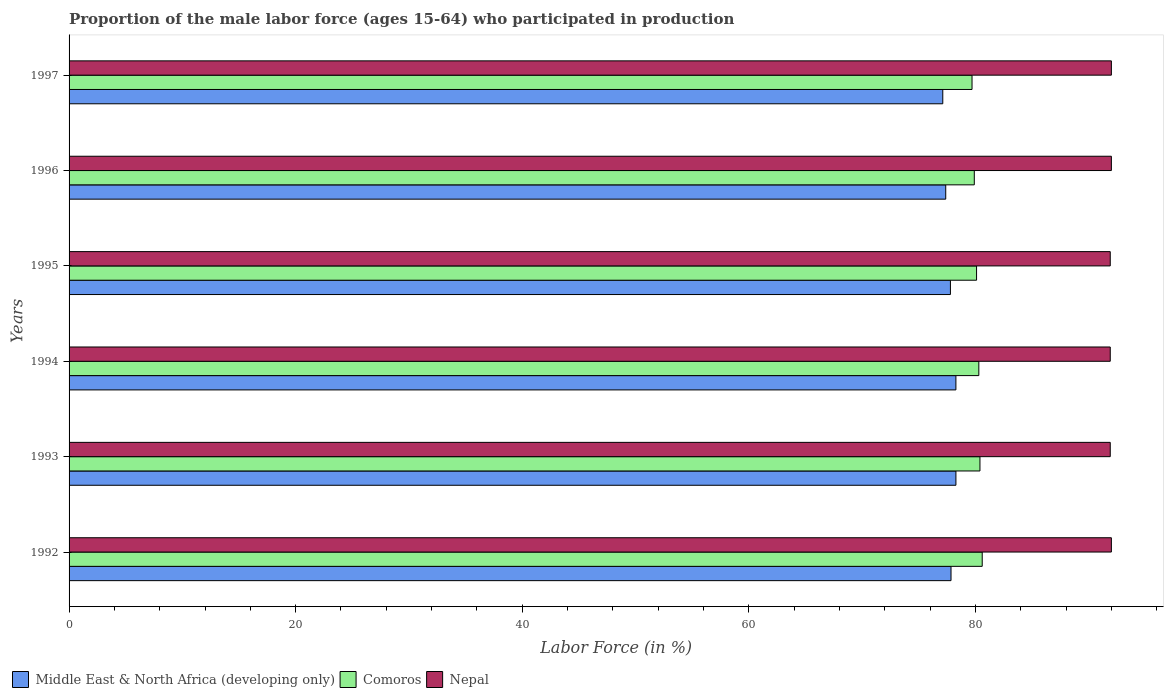How many different coloured bars are there?
Offer a very short reply. 3. How many groups of bars are there?
Keep it short and to the point. 6. Are the number of bars per tick equal to the number of legend labels?
Your response must be concise. Yes. How many bars are there on the 5th tick from the top?
Give a very brief answer. 3. How many bars are there on the 4th tick from the bottom?
Your response must be concise. 3. In how many cases, is the number of bars for a given year not equal to the number of legend labels?
Make the answer very short. 0. What is the proportion of the male labor force who participated in production in Comoros in 1997?
Make the answer very short. 79.7. Across all years, what is the maximum proportion of the male labor force who participated in production in Middle East & North Africa (developing only)?
Your response must be concise. 78.28. Across all years, what is the minimum proportion of the male labor force who participated in production in Comoros?
Your answer should be compact. 79.7. What is the total proportion of the male labor force who participated in production in Nepal in the graph?
Provide a short and direct response. 551.7. What is the difference between the proportion of the male labor force who participated in production in Middle East & North Africa (developing only) in 1994 and that in 1995?
Your answer should be very brief. 0.48. What is the difference between the proportion of the male labor force who participated in production in Comoros in 1994 and the proportion of the male labor force who participated in production in Middle East & North Africa (developing only) in 1992?
Keep it short and to the point. 2.45. What is the average proportion of the male labor force who participated in production in Comoros per year?
Make the answer very short. 80.17. In the year 1995, what is the difference between the proportion of the male labor force who participated in production in Nepal and proportion of the male labor force who participated in production in Middle East & North Africa (developing only)?
Provide a short and direct response. 14.11. In how many years, is the proportion of the male labor force who participated in production in Comoros greater than 76 %?
Make the answer very short. 6. What is the ratio of the proportion of the male labor force who participated in production in Comoros in 1992 to that in 1994?
Make the answer very short. 1. Is the proportion of the male labor force who participated in production in Middle East & North Africa (developing only) in 1993 less than that in 1997?
Provide a succinct answer. No. What is the difference between the highest and the second highest proportion of the male labor force who participated in production in Comoros?
Keep it short and to the point. 0.2. What is the difference between the highest and the lowest proportion of the male labor force who participated in production in Comoros?
Offer a terse response. 0.9. What does the 2nd bar from the top in 1996 represents?
Make the answer very short. Comoros. What does the 1st bar from the bottom in 1995 represents?
Your answer should be compact. Middle East & North Africa (developing only). How many bars are there?
Ensure brevity in your answer.  18. Are all the bars in the graph horizontal?
Your response must be concise. Yes. Are the values on the major ticks of X-axis written in scientific E-notation?
Make the answer very short. No. Does the graph contain any zero values?
Offer a terse response. No. Does the graph contain grids?
Offer a terse response. No. How many legend labels are there?
Provide a short and direct response. 3. How are the legend labels stacked?
Your response must be concise. Horizontal. What is the title of the graph?
Keep it short and to the point. Proportion of the male labor force (ages 15-64) who participated in production. What is the Labor Force (in %) of Middle East & North Africa (developing only) in 1992?
Offer a terse response. 77.85. What is the Labor Force (in %) in Comoros in 1992?
Your answer should be very brief. 80.6. What is the Labor Force (in %) of Nepal in 1992?
Make the answer very short. 92. What is the Labor Force (in %) of Middle East & North Africa (developing only) in 1993?
Your answer should be compact. 78.28. What is the Labor Force (in %) in Comoros in 1993?
Your answer should be compact. 80.4. What is the Labor Force (in %) in Nepal in 1993?
Ensure brevity in your answer.  91.9. What is the Labor Force (in %) in Middle East & North Africa (developing only) in 1994?
Make the answer very short. 78.28. What is the Labor Force (in %) of Comoros in 1994?
Keep it short and to the point. 80.3. What is the Labor Force (in %) in Nepal in 1994?
Your answer should be very brief. 91.9. What is the Labor Force (in %) of Middle East & North Africa (developing only) in 1995?
Offer a very short reply. 77.79. What is the Labor Force (in %) in Comoros in 1995?
Offer a terse response. 80.1. What is the Labor Force (in %) of Nepal in 1995?
Your response must be concise. 91.9. What is the Labor Force (in %) of Middle East & North Africa (developing only) in 1996?
Ensure brevity in your answer.  77.38. What is the Labor Force (in %) of Comoros in 1996?
Ensure brevity in your answer.  79.9. What is the Labor Force (in %) in Nepal in 1996?
Your answer should be compact. 92. What is the Labor Force (in %) of Middle East & North Africa (developing only) in 1997?
Provide a succinct answer. 77.12. What is the Labor Force (in %) in Comoros in 1997?
Your answer should be compact. 79.7. What is the Labor Force (in %) of Nepal in 1997?
Offer a terse response. 92. Across all years, what is the maximum Labor Force (in %) of Middle East & North Africa (developing only)?
Ensure brevity in your answer.  78.28. Across all years, what is the maximum Labor Force (in %) of Comoros?
Keep it short and to the point. 80.6. Across all years, what is the maximum Labor Force (in %) in Nepal?
Offer a very short reply. 92. Across all years, what is the minimum Labor Force (in %) in Middle East & North Africa (developing only)?
Offer a terse response. 77.12. Across all years, what is the minimum Labor Force (in %) in Comoros?
Give a very brief answer. 79.7. Across all years, what is the minimum Labor Force (in %) in Nepal?
Make the answer very short. 91.9. What is the total Labor Force (in %) of Middle East & North Africa (developing only) in the graph?
Make the answer very short. 466.69. What is the total Labor Force (in %) of Comoros in the graph?
Make the answer very short. 481. What is the total Labor Force (in %) in Nepal in the graph?
Keep it short and to the point. 551.7. What is the difference between the Labor Force (in %) of Middle East & North Africa (developing only) in 1992 and that in 1993?
Your response must be concise. -0.43. What is the difference between the Labor Force (in %) of Comoros in 1992 and that in 1993?
Offer a very short reply. 0.2. What is the difference between the Labor Force (in %) of Middle East & North Africa (developing only) in 1992 and that in 1994?
Your answer should be compact. -0.43. What is the difference between the Labor Force (in %) of Middle East & North Africa (developing only) in 1992 and that in 1995?
Keep it short and to the point. 0.05. What is the difference between the Labor Force (in %) in Comoros in 1992 and that in 1995?
Your answer should be compact. 0.5. What is the difference between the Labor Force (in %) of Middle East & North Africa (developing only) in 1992 and that in 1996?
Make the answer very short. 0.47. What is the difference between the Labor Force (in %) of Middle East & North Africa (developing only) in 1992 and that in 1997?
Keep it short and to the point. 0.73. What is the difference between the Labor Force (in %) of Nepal in 1992 and that in 1997?
Provide a succinct answer. 0. What is the difference between the Labor Force (in %) of Middle East & North Africa (developing only) in 1993 and that in 1994?
Offer a terse response. 0. What is the difference between the Labor Force (in %) of Middle East & North Africa (developing only) in 1993 and that in 1995?
Your answer should be compact. 0.49. What is the difference between the Labor Force (in %) of Middle East & North Africa (developing only) in 1993 and that in 1996?
Ensure brevity in your answer.  0.9. What is the difference between the Labor Force (in %) in Nepal in 1993 and that in 1996?
Ensure brevity in your answer.  -0.1. What is the difference between the Labor Force (in %) of Middle East & North Africa (developing only) in 1993 and that in 1997?
Give a very brief answer. 1.16. What is the difference between the Labor Force (in %) of Nepal in 1993 and that in 1997?
Give a very brief answer. -0.1. What is the difference between the Labor Force (in %) in Middle East & North Africa (developing only) in 1994 and that in 1995?
Your response must be concise. 0.48. What is the difference between the Labor Force (in %) of Nepal in 1994 and that in 1995?
Your response must be concise. 0. What is the difference between the Labor Force (in %) in Middle East & North Africa (developing only) in 1994 and that in 1996?
Your answer should be very brief. 0.9. What is the difference between the Labor Force (in %) in Comoros in 1994 and that in 1996?
Your response must be concise. 0.4. What is the difference between the Labor Force (in %) of Middle East & North Africa (developing only) in 1994 and that in 1997?
Offer a terse response. 1.16. What is the difference between the Labor Force (in %) in Middle East & North Africa (developing only) in 1995 and that in 1996?
Offer a terse response. 0.41. What is the difference between the Labor Force (in %) of Middle East & North Africa (developing only) in 1995 and that in 1997?
Make the answer very short. 0.67. What is the difference between the Labor Force (in %) of Comoros in 1995 and that in 1997?
Ensure brevity in your answer.  0.4. What is the difference between the Labor Force (in %) in Middle East & North Africa (developing only) in 1996 and that in 1997?
Provide a short and direct response. 0.26. What is the difference between the Labor Force (in %) in Comoros in 1996 and that in 1997?
Provide a short and direct response. 0.2. What is the difference between the Labor Force (in %) in Middle East & North Africa (developing only) in 1992 and the Labor Force (in %) in Comoros in 1993?
Your answer should be compact. -2.55. What is the difference between the Labor Force (in %) in Middle East & North Africa (developing only) in 1992 and the Labor Force (in %) in Nepal in 1993?
Offer a very short reply. -14.05. What is the difference between the Labor Force (in %) of Middle East & North Africa (developing only) in 1992 and the Labor Force (in %) of Comoros in 1994?
Offer a terse response. -2.45. What is the difference between the Labor Force (in %) in Middle East & North Africa (developing only) in 1992 and the Labor Force (in %) in Nepal in 1994?
Provide a succinct answer. -14.05. What is the difference between the Labor Force (in %) of Comoros in 1992 and the Labor Force (in %) of Nepal in 1994?
Provide a short and direct response. -11.3. What is the difference between the Labor Force (in %) of Middle East & North Africa (developing only) in 1992 and the Labor Force (in %) of Comoros in 1995?
Provide a short and direct response. -2.25. What is the difference between the Labor Force (in %) in Middle East & North Africa (developing only) in 1992 and the Labor Force (in %) in Nepal in 1995?
Provide a short and direct response. -14.05. What is the difference between the Labor Force (in %) of Comoros in 1992 and the Labor Force (in %) of Nepal in 1995?
Keep it short and to the point. -11.3. What is the difference between the Labor Force (in %) of Middle East & North Africa (developing only) in 1992 and the Labor Force (in %) of Comoros in 1996?
Give a very brief answer. -2.05. What is the difference between the Labor Force (in %) of Middle East & North Africa (developing only) in 1992 and the Labor Force (in %) of Nepal in 1996?
Offer a terse response. -14.15. What is the difference between the Labor Force (in %) in Comoros in 1992 and the Labor Force (in %) in Nepal in 1996?
Offer a very short reply. -11.4. What is the difference between the Labor Force (in %) of Middle East & North Africa (developing only) in 1992 and the Labor Force (in %) of Comoros in 1997?
Give a very brief answer. -1.85. What is the difference between the Labor Force (in %) of Middle East & North Africa (developing only) in 1992 and the Labor Force (in %) of Nepal in 1997?
Ensure brevity in your answer.  -14.15. What is the difference between the Labor Force (in %) in Middle East & North Africa (developing only) in 1993 and the Labor Force (in %) in Comoros in 1994?
Keep it short and to the point. -2.02. What is the difference between the Labor Force (in %) of Middle East & North Africa (developing only) in 1993 and the Labor Force (in %) of Nepal in 1994?
Ensure brevity in your answer.  -13.62. What is the difference between the Labor Force (in %) in Middle East & North Africa (developing only) in 1993 and the Labor Force (in %) in Comoros in 1995?
Your answer should be compact. -1.82. What is the difference between the Labor Force (in %) in Middle East & North Africa (developing only) in 1993 and the Labor Force (in %) in Nepal in 1995?
Your answer should be very brief. -13.62. What is the difference between the Labor Force (in %) in Middle East & North Africa (developing only) in 1993 and the Labor Force (in %) in Comoros in 1996?
Offer a terse response. -1.62. What is the difference between the Labor Force (in %) in Middle East & North Africa (developing only) in 1993 and the Labor Force (in %) in Nepal in 1996?
Offer a terse response. -13.72. What is the difference between the Labor Force (in %) of Comoros in 1993 and the Labor Force (in %) of Nepal in 1996?
Make the answer very short. -11.6. What is the difference between the Labor Force (in %) of Middle East & North Africa (developing only) in 1993 and the Labor Force (in %) of Comoros in 1997?
Offer a terse response. -1.42. What is the difference between the Labor Force (in %) of Middle East & North Africa (developing only) in 1993 and the Labor Force (in %) of Nepal in 1997?
Provide a succinct answer. -13.72. What is the difference between the Labor Force (in %) of Middle East & North Africa (developing only) in 1994 and the Labor Force (in %) of Comoros in 1995?
Give a very brief answer. -1.82. What is the difference between the Labor Force (in %) of Middle East & North Africa (developing only) in 1994 and the Labor Force (in %) of Nepal in 1995?
Your response must be concise. -13.62. What is the difference between the Labor Force (in %) in Middle East & North Africa (developing only) in 1994 and the Labor Force (in %) in Comoros in 1996?
Make the answer very short. -1.62. What is the difference between the Labor Force (in %) in Middle East & North Africa (developing only) in 1994 and the Labor Force (in %) in Nepal in 1996?
Provide a short and direct response. -13.72. What is the difference between the Labor Force (in %) in Comoros in 1994 and the Labor Force (in %) in Nepal in 1996?
Provide a succinct answer. -11.7. What is the difference between the Labor Force (in %) in Middle East & North Africa (developing only) in 1994 and the Labor Force (in %) in Comoros in 1997?
Offer a terse response. -1.42. What is the difference between the Labor Force (in %) in Middle East & North Africa (developing only) in 1994 and the Labor Force (in %) in Nepal in 1997?
Your answer should be very brief. -13.72. What is the difference between the Labor Force (in %) of Comoros in 1994 and the Labor Force (in %) of Nepal in 1997?
Provide a short and direct response. -11.7. What is the difference between the Labor Force (in %) in Middle East & North Africa (developing only) in 1995 and the Labor Force (in %) in Comoros in 1996?
Your answer should be compact. -2.11. What is the difference between the Labor Force (in %) of Middle East & North Africa (developing only) in 1995 and the Labor Force (in %) of Nepal in 1996?
Keep it short and to the point. -14.21. What is the difference between the Labor Force (in %) of Comoros in 1995 and the Labor Force (in %) of Nepal in 1996?
Keep it short and to the point. -11.9. What is the difference between the Labor Force (in %) in Middle East & North Africa (developing only) in 1995 and the Labor Force (in %) in Comoros in 1997?
Your answer should be very brief. -1.91. What is the difference between the Labor Force (in %) in Middle East & North Africa (developing only) in 1995 and the Labor Force (in %) in Nepal in 1997?
Your response must be concise. -14.21. What is the difference between the Labor Force (in %) of Comoros in 1995 and the Labor Force (in %) of Nepal in 1997?
Offer a terse response. -11.9. What is the difference between the Labor Force (in %) of Middle East & North Africa (developing only) in 1996 and the Labor Force (in %) of Comoros in 1997?
Your answer should be very brief. -2.32. What is the difference between the Labor Force (in %) of Middle East & North Africa (developing only) in 1996 and the Labor Force (in %) of Nepal in 1997?
Provide a succinct answer. -14.62. What is the difference between the Labor Force (in %) in Comoros in 1996 and the Labor Force (in %) in Nepal in 1997?
Provide a short and direct response. -12.1. What is the average Labor Force (in %) in Middle East & North Africa (developing only) per year?
Provide a succinct answer. 77.78. What is the average Labor Force (in %) in Comoros per year?
Your answer should be compact. 80.17. What is the average Labor Force (in %) of Nepal per year?
Offer a terse response. 91.95. In the year 1992, what is the difference between the Labor Force (in %) in Middle East & North Africa (developing only) and Labor Force (in %) in Comoros?
Your answer should be compact. -2.75. In the year 1992, what is the difference between the Labor Force (in %) in Middle East & North Africa (developing only) and Labor Force (in %) in Nepal?
Your answer should be compact. -14.15. In the year 1992, what is the difference between the Labor Force (in %) of Comoros and Labor Force (in %) of Nepal?
Provide a short and direct response. -11.4. In the year 1993, what is the difference between the Labor Force (in %) of Middle East & North Africa (developing only) and Labor Force (in %) of Comoros?
Keep it short and to the point. -2.12. In the year 1993, what is the difference between the Labor Force (in %) of Middle East & North Africa (developing only) and Labor Force (in %) of Nepal?
Make the answer very short. -13.62. In the year 1994, what is the difference between the Labor Force (in %) in Middle East & North Africa (developing only) and Labor Force (in %) in Comoros?
Give a very brief answer. -2.02. In the year 1994, what is the difference between the Labor Force (in %) in Middle East & North Africa (developing only) and Labor Force (in %) in Nepal?
Your response must be concise. -13.62. In the year 1994, what is the difference between the Labor Force (in %) of Comoros and Labor Force (in %) of Nepal?
Offer a terse response. -11.6. In the year 1995, what is the difference between the Labor Force (in %) in Middle East & North Africa (developing only) and Labor Force (in %) in Comoros?
Make the answer very short. -2.31. In the year 1995, what is the difference between the Labor Force (in %) in Middle East & North Africa (developing only) and Labor Force (in %) in Nepal?
Ensure brevity in your answer.  -14.11. In the year 1995, what is the difference between the Labor Force (in %) of Comoros and Labor Force (in %) of Nepal?
Provide a short and direct response. -11.8. In the year 1996, what is the difference between the Labor Force (in %) of Middle East & North Africa (developing only) and Labor Force (in %) of Comoros?
Your answer should be very brief. -2.52. In the year 1996, what is the difference between the Labor Force (in %) in Middle East & North Africa (developing only) and Labor Force (in %) in Nepal?
Offer a terse response. -14.62. In the year 1996, what is the difference between the Labor Force (in %) in Comoros and Labor Force (in %) in Nepal?
Your answer should be compact. -12.1. In the year 1997, what is the difference between the Labor Force (in %) in Middle East & North Africa (developing only) and Labor Force (in %) in Comoros?
Ensure brevity in your answer.  -2.58. In the year 1997, what is the difference between the Labor Force (in %) in Middle East & North Africa (developing only) and Labor Force (in %) in Nepal?
Your response must be concise. -14.88. What is the ratio of the Labor Force (in %) in Comoros in 1992 to that in 1993?
Offer a terse response. 1. What is the ratio of the Labor Force (in %) in Nepal in 1992 to that in 1993?
Offer a very short reply. 1. What is the ratio of the Labor Force (in %) of Middle East & North Africa (developing only) in 1992 to that in 1994?
Your answer should be very brief. 0.99. What is the ratio of the Labor Force (in %) in Middle East & North Africa (developing only) in 1992 to that in 1995?
Your answer should be compact. 1. What is the ratio of the Labor Force (in %) of Comoros in 1992 to that in 1995?
Offer a very short reply. 1.01. What is the ratio of the Labor Force (in %) of Middle East & North Africa (developing only) in 1992 to that in 1996?
Make the answer very short. 1.01. What is the ratio of the Labor Force (in %) of Comoros in 1992 to that in 1996?
Offer a terse response. 1.01. What is the ratio of the Labor Force (in %) in Nepal in 1992 to that in 1996?
Provide a succinct answer. 1. What is the ratio of the Labor Force (in %) of Middle East & North Africa (developing only) in 1992 to that in 1997?
Your answer should be very brief. 1.01. What is the ratio of the Labor Force (in %) in Comoros in 1992 to that in 1997?
Offer a terse response. 1.01. What is the ratio of the Labor Force (in %) in Comoros in 1993 to that in 1994?
Provide a short and direct response. 1. What is the ratio of the Labor Force (in %) in Middle East & North Africa (developing only) in 1993 to that in 1995?
Offer a very short reply. 1.01. What is the ratio of the Labor Force (in %) in Comoros in 1993 to that in 1995?
Make the answer very short. 1. What is the ratio of the Labor Force (in %) of Nepal in 1993 to that in 1995?
Offer a terse response. 1. What is the ratio of the Labor Force (in %) of Middle East & North Africa (developing only) in 1993 to that in 1996?
Your answer should be very brief. 1.01. What is the ratio of the Labor Force (in %) of Comoros in 1993 to that in 1996?
Offer a terse response. 1.01. What is the ratio of the Labor Force (in %) in Comoros in 1993 to that in 1997?
Give a very brief answer. 1.01. What is the ratio of the Labor Force (in %) in Nepal in 1993 to that in 1997?
Ensure brevity in your answer.  1. What is the ratio of the Labor Force (in %) in Middle East & North Africa (developing only) in 1994 to that in 1995?
Provide a short and direct response. 1.01. What is the ratio of the Labor Force (in %) in Nepal in 1994 to that in 1995?
Your answer should be compact. 1. What is the ratio of the Labor Force (in %) of Middle East & North Africa (developing only) in 1994 to that in 1996?
Ensure brevity in your answer.  1.01. What is the ratio of the Labor Force (in %) in Middle East & North Africa (developing only) in 1994 to that in 1997?
Offer a very short reply. 1.01. What is the ratio of the Labor Force (in %) in Comoros in 1994 to that in 1997?
Provide a short and direct response. 1.01. What is the ratio of the Labor Force (in %) of Nepal in 1994 to that in 1997?
Provide a short and direct response. 1. What is the ratio of the Labor Force (in %) of Comoros in 1995 to that in 1996?
Ensure brevity in your answer.  1. What is the ratio of the Labor Force (in %) in Nepal in 1995 to that in 1996?
Your response must be concise. 1. What is the ratio of the Labor Force (in %) of Middle East & North Africa (developing only) in 1995 to that in 1997?
Offer a terse response. 1.01. What is the ratio of the Labor Force (in %) in Comoros in 1995 to that in 1997?
Keep it short and to the point. 1. What is the ratio of the Labor Force (in %) of Comoros in 1996 to that in 1997?
Offer a terse response. 1. What is the ratio of the Labor Force (in %) of Nepal in 1996 to that in 1997?
Offer a very short reply. 1. What is the difference between the highest and the second highest Labor Force (in %) of Middle East & North Africa (developing only)?
Your answer should be very brief. 0. What is the difference between the highest and the lowest Labor Force (in %) in Middle East & North Africa (developing only)?
Give a very brief answer. 1.16. What is the difference between the highest and the lowest Labor Force (in %) of Comoros?
Ensure brevity in your answer.  0.9. 